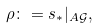Convert formula to latex. <formula><loc_0><loc_0><loc_500><loc_500>\rho \colon = s _ { \ast } | _ { A \mathcal { G } } ,</formula> 